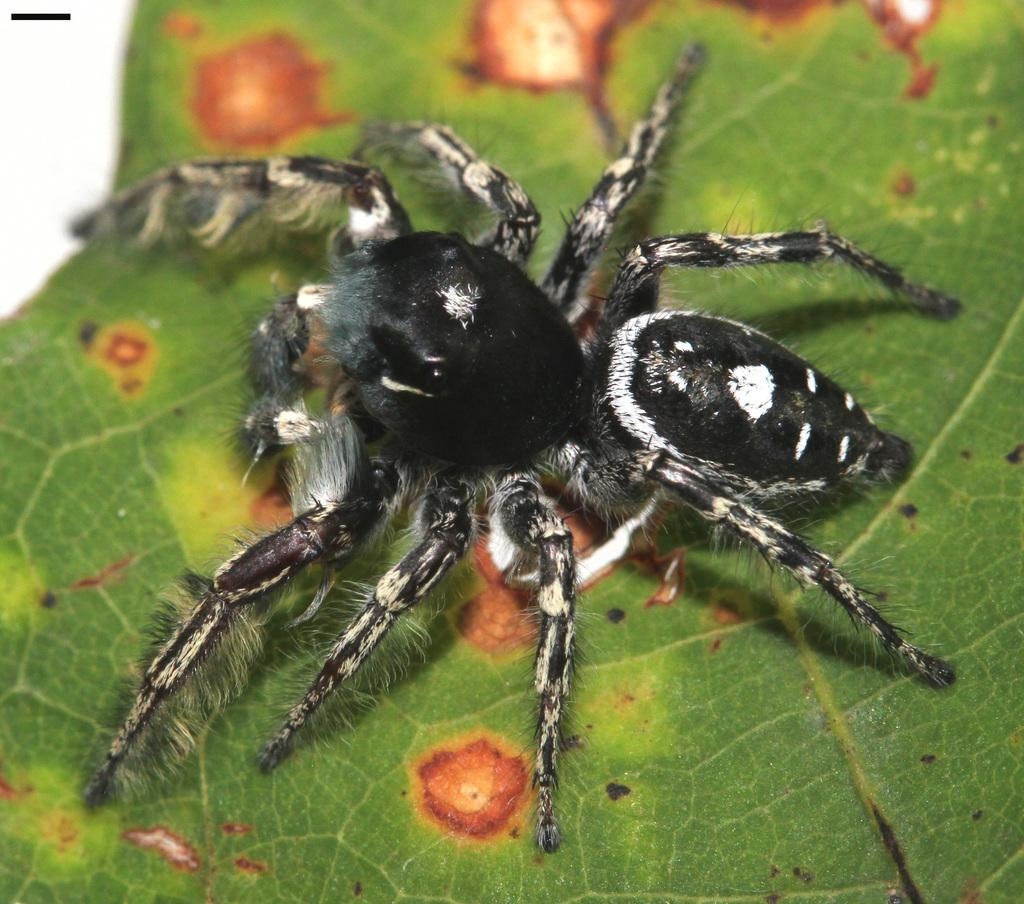What is present in the picture? There is an insect in the picture. What color is the insect? A: The insect is black in color. Where is the insect located in the picture? The insect is on a green leaf. What type of basketball game is being played in the image? There is no basketball game present in the image; it features an insect on a green leaf. What is the answer to the question about the existence of the insect in the image? The insect does exist in the image, as it is one of the main subjects. 